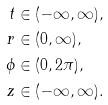<formula> <loc_0><loc_0><loc_500><loc_500>t & \in ( - \infty , \infty ) , \\ r & \in ( 0 , \infty ) , \\ \phi & \in ( 0 , 2 \pi ) , \\ z & \in ( - \infty , \infty ) .</formula> 